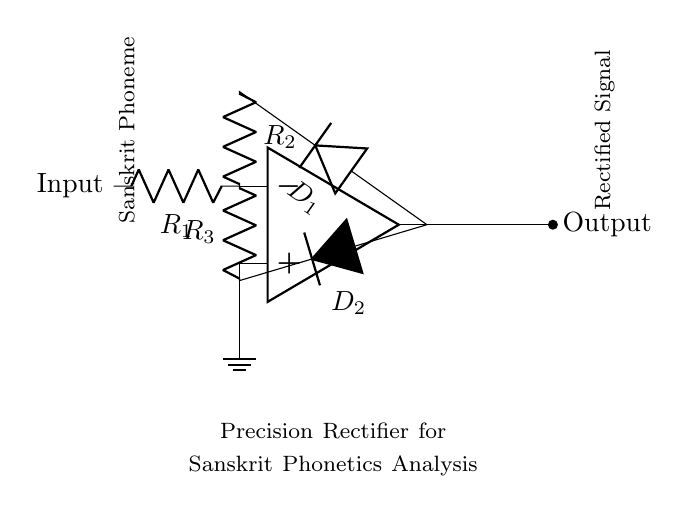What type of circuit is represented here? The circuit is a precision rectifier, indicated by the configuration with operational amplifiers and diodes used for rectification.
Answer: precision rectifier What is the role of R1 in this circuit? R1 is the input resistor that connects the input signal to the inverting input of the operational amplifier, influencing gain and signal processing.
Answer: input resistor How many diodes are present in the circuit? The circuit contains two diodes, D1 and D2, which are used for the rectification process by allowing current to flow only in one direction.
Answer: two What does the output represent? The output represents the rectified signal derived from the input Sanskrit phoneme, processed through the precision rectifier circuit.
Answer: rectified signal What is the significance of using an operational amplifier in this circuit? The operational amplifier allows for high precision in rectifying the input signal and providing a controlled gain, which is crucial for accurately analyzing phonetics.
Answer: high precision What happens to the signal if the diodes are reversed? If the diodes are reversed, the circuit would effectively block the input signal from being rectified, preventing correct signal processing and analysis of phonetics.
Answer: block input signal What does the label "Sanskrit Phoneme" signify in this circuit? The label indicates that the input signal being processed corresponds to the sounds or phonetic elements of Sanskrit, essential for phonetic analysis.
Answer: input signal source 